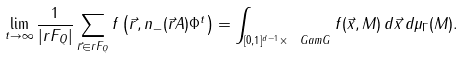<formula> <loc_0><loc_0><loc_500><loc_500>\lim _ { t \to \infty } \frac { 1 } { | r F _ { Q } | } \sum _ { \vec { r } \in r F _ { Q } } f \left ( \vec { r } , n _ { - } ( \vec { r } A ) \Phi ^ { t } \right ) = \int _ { [ 0 , 1 ] ^ { d - 1 } \times \ G a m G } f ( \vec { x } , M ) \, d \vec { x } \, d \mu _ { \Gamma } ( M ) .</formula> 